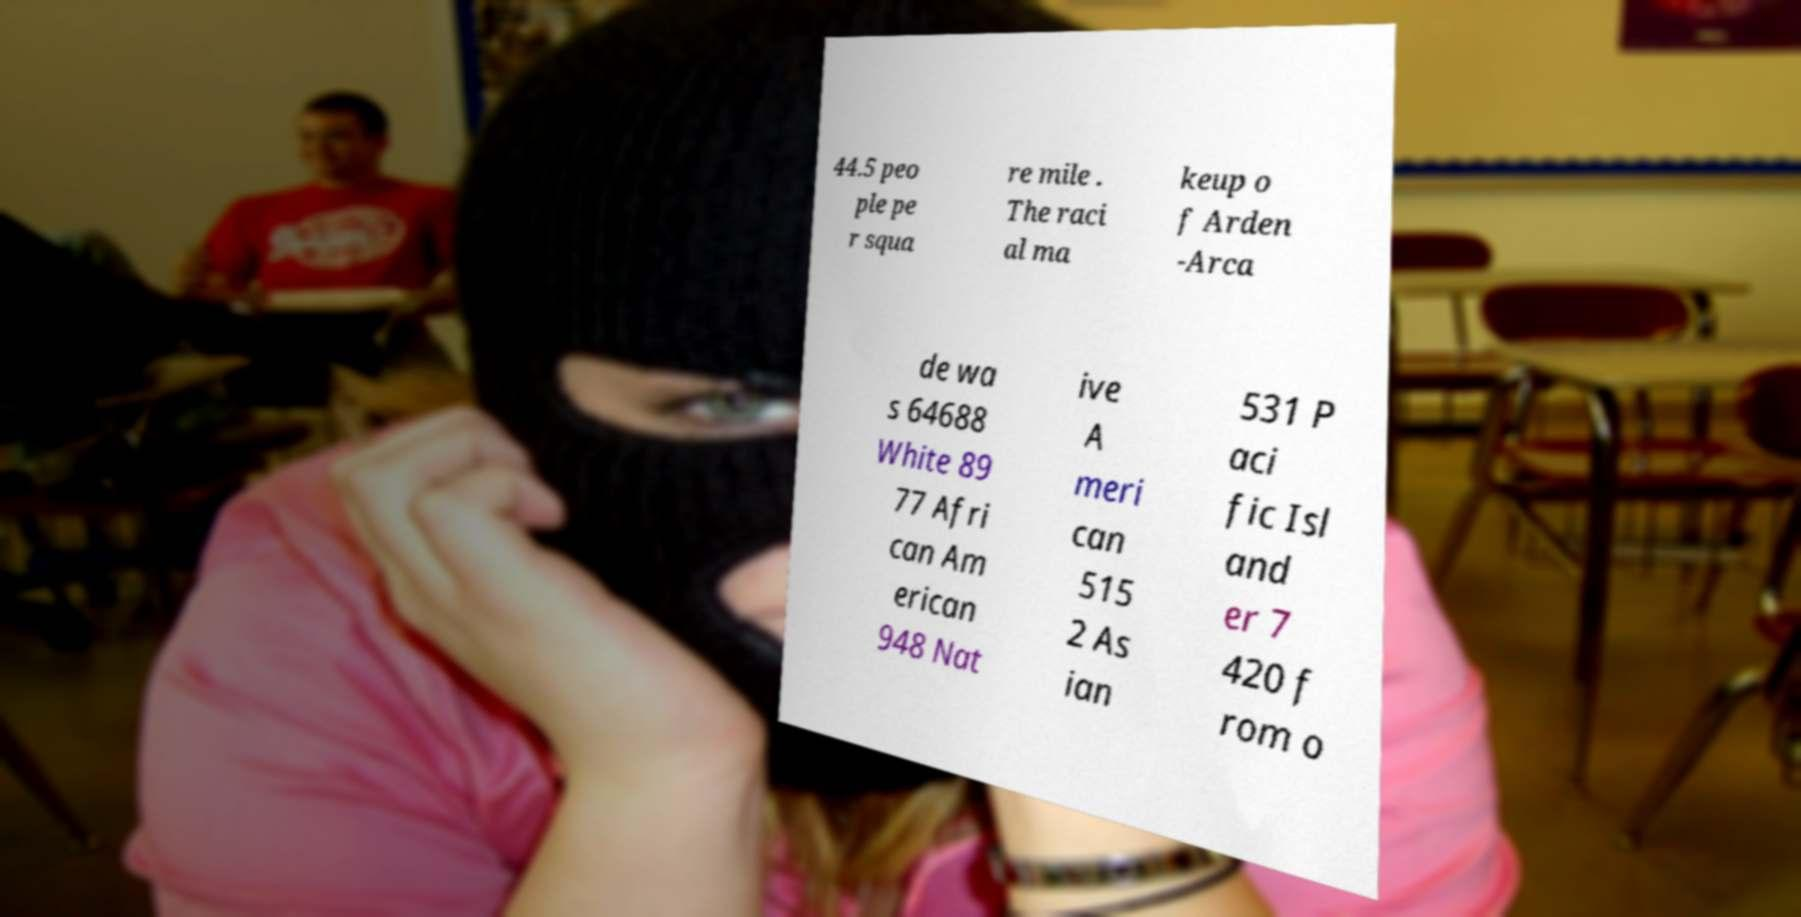There's text embedded in this image that I need extracted. Can you transcribe it verbatim? 44.5 peo ple pe r squa re mile . The raci al ma keup o f Arden -Arca de wa s 64688 White 89 77 Afri can Am erican 948 Nat ive A meri can 515 2 As ian 531 P aci fic Isl and er 7 420 f rom o 